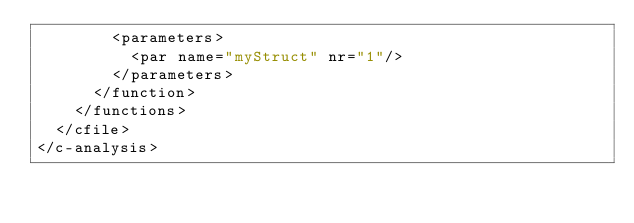<code> <loc_0><loc_0><loc_500><loc_500><_XML_>        <parameters>
          <par name="myStruct" nr="1"/>
        </parameters>
      </function>
    </functions>
  </cfile>
</c-analysis>
</code> 